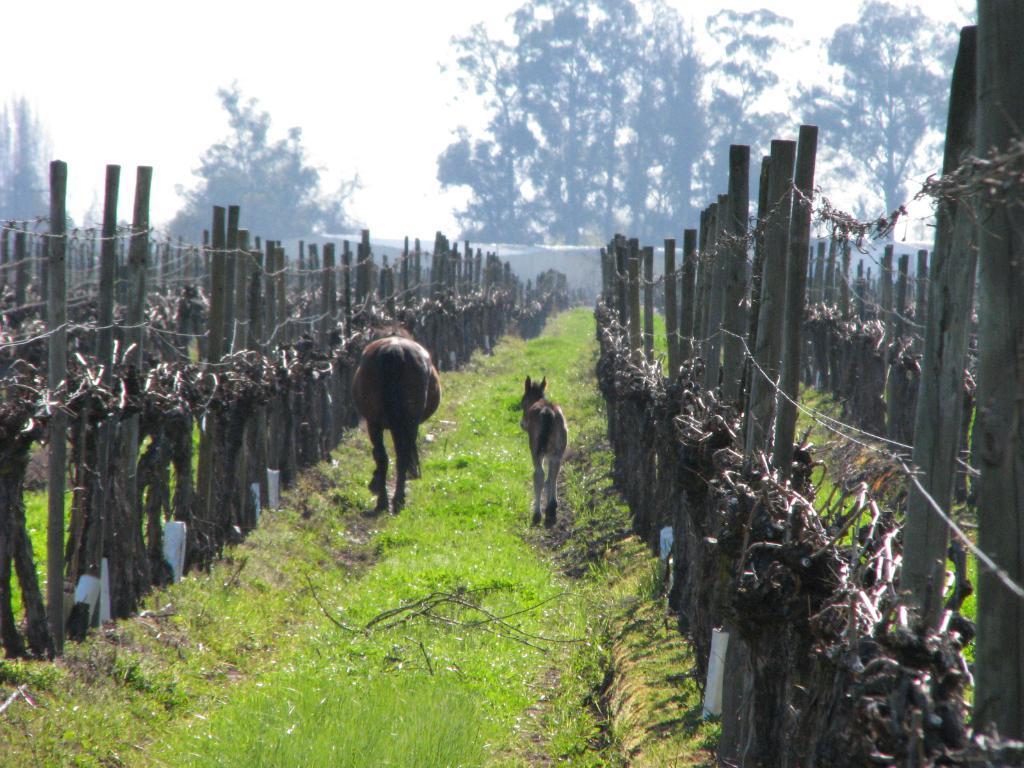Can you describe this image briefly? In this image we can see animals on the grassy land. On the both sides of the image, we can see fencing. There are trees and the sky in the background. 